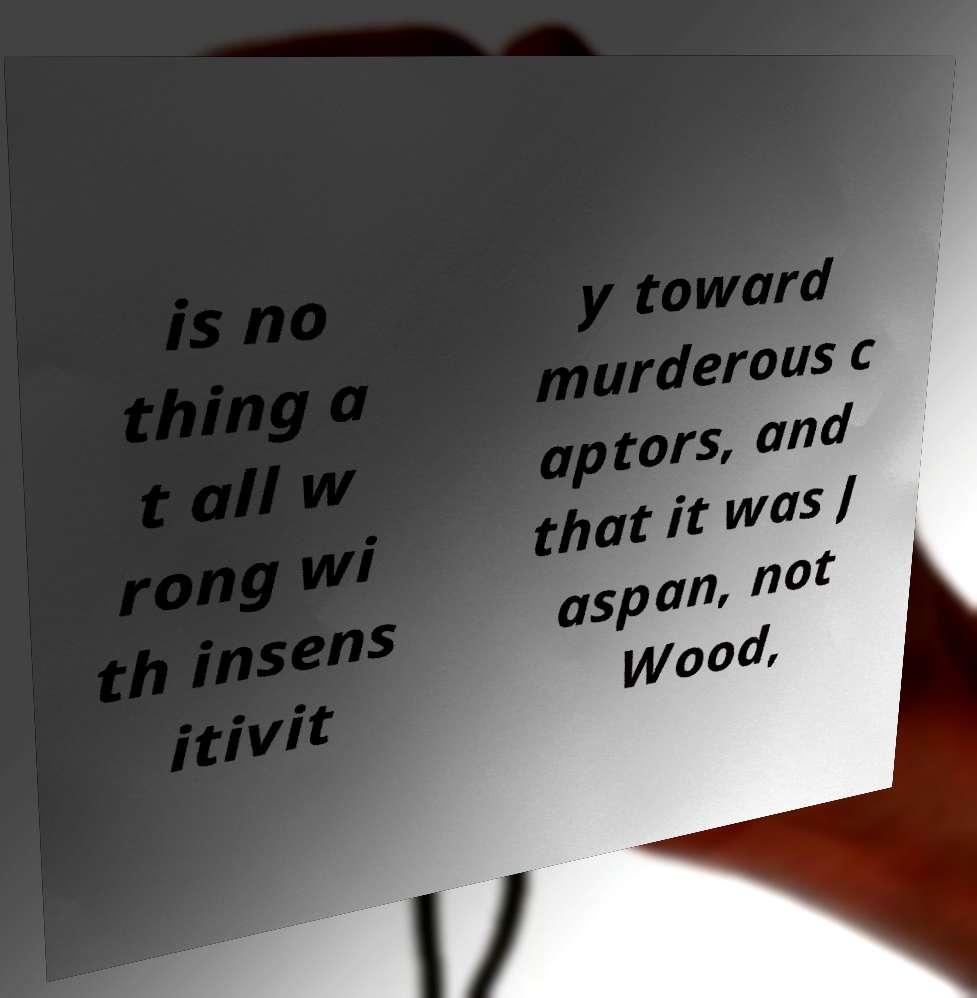Please identify and transcribe the text found in this image. is no thing a t all w rong wi th insens itivit y toward murderous c aptors, and that it was J aspan, not Wood, 